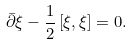<formula> <loc_0><loc_0><loc_500><loc_500>\bar { \partial } \xi - \frac { 1 } { 2 } \left [ \xi , \xi \right ] = 0 .</formula> 